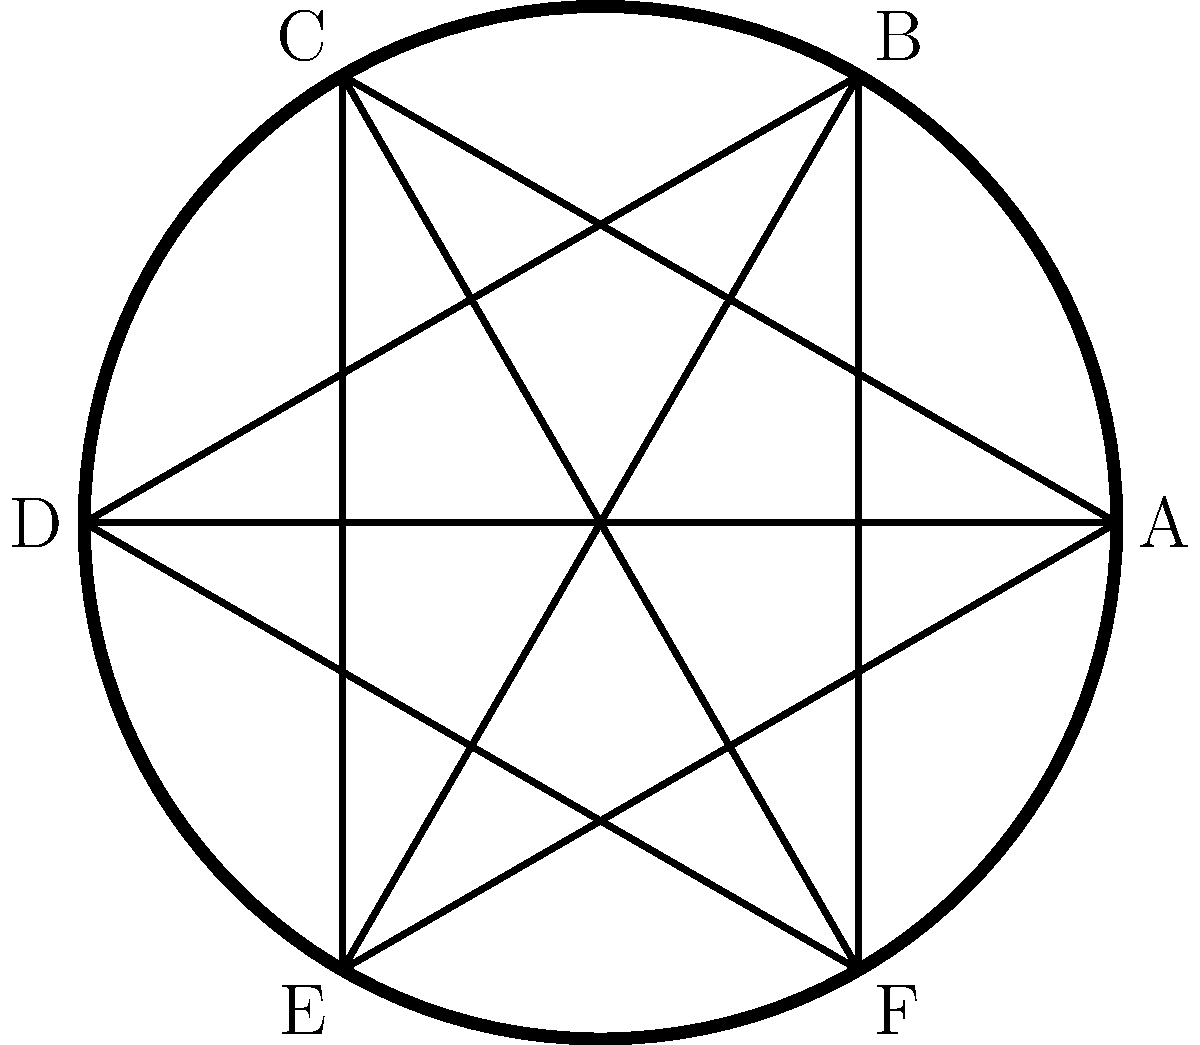In the Viking shield design shown above, how many lines of symmetry does the pattern have? To determine the number of lines of symmetry in this Viking shield design, we need to analyze the pattern and identify all the lines that divide the shield into two identical halves. Let's approach this step-by-step:

1. Rotational Symmetry:
   The shield has a circular shape with six equally spaced points (A, B, C, D, E, F) around its circumference.

2. Radial Lines:
   There are six radial lines connecting the center to each of these points.

3. Triangular Patterns:
   Two equilateral triangles are formed by connecting alternate points (ACE and BDF).

4. Lines of Symmetry:
   a) Through opposite points:
      - Line AD
      - Line BE
      - Line CF
   These three lines divide the shield into two identical halves.

   b) Through midpoints between adjacent points:
      - Line bisecting arc AB and arc DE
      - Line bisecting arc BC and arc EF
      - Line bisecting arc CD and arc FA
   These three lines also divide the shield into two identical halves.

5. Total Lines of Symmetry:
   The shield has 3 + 3 = 6 lines of symmetry in total.

Each of these six lines divides the entire pattern (including the circular shield, the radial lines, and the two triangles) into two mirror images of each other, satisfying the definition of a line of symmetry.
Answer: 6 lines of symmetry 